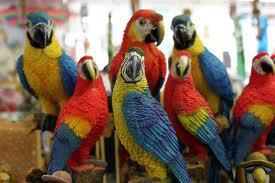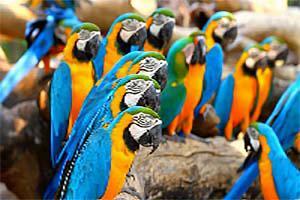The first image is the image on the left, the second image is the image on the right. Evaluate the accuracy of this statement regarding the images: "One image contains exactly six birds.". Is it true? Answer yes or no. No. 